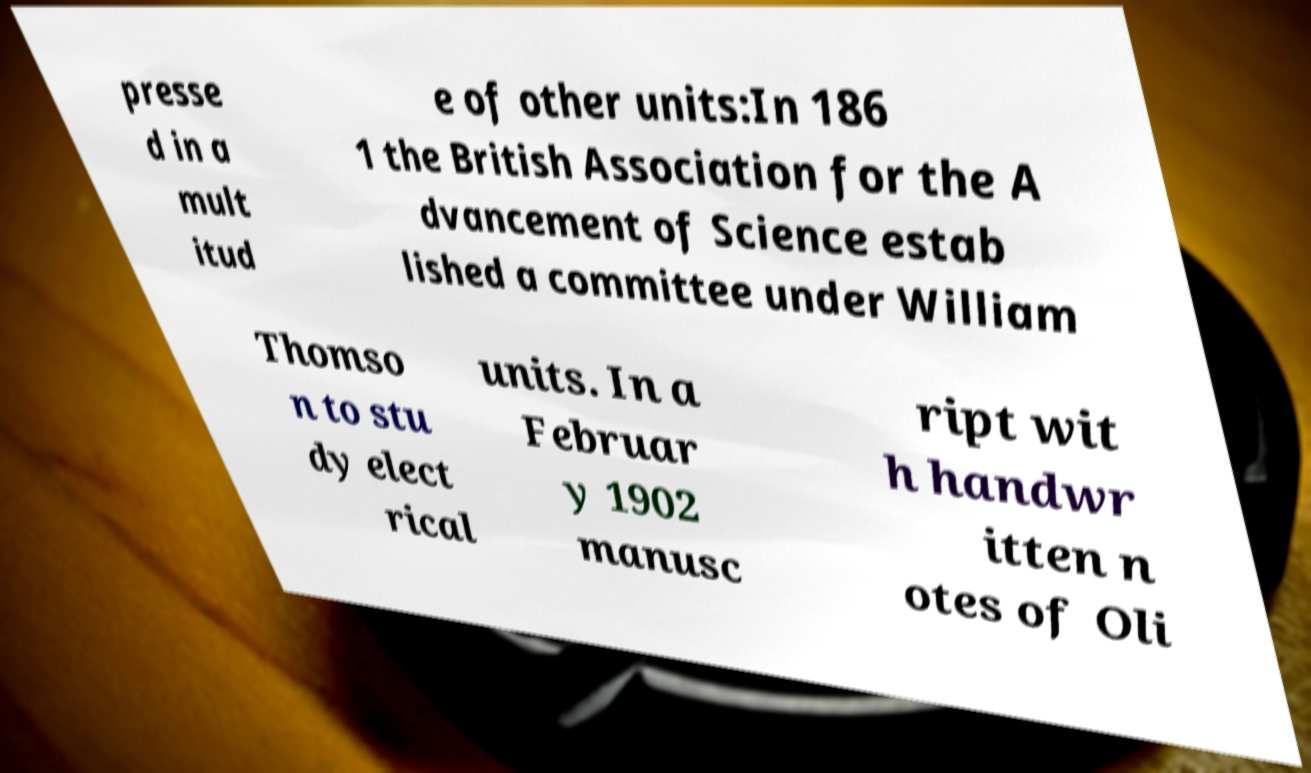Can you accurately transcribe the text from the provided image for me? presse d in a mult itud e of other units:In 186 1 the British Association for the A dvancement of Science estab lished a committee under William Thomso n to stu dy elect rical units. In a Februar y 1902 manusc ript wit h handwr itten n otes of Oli 